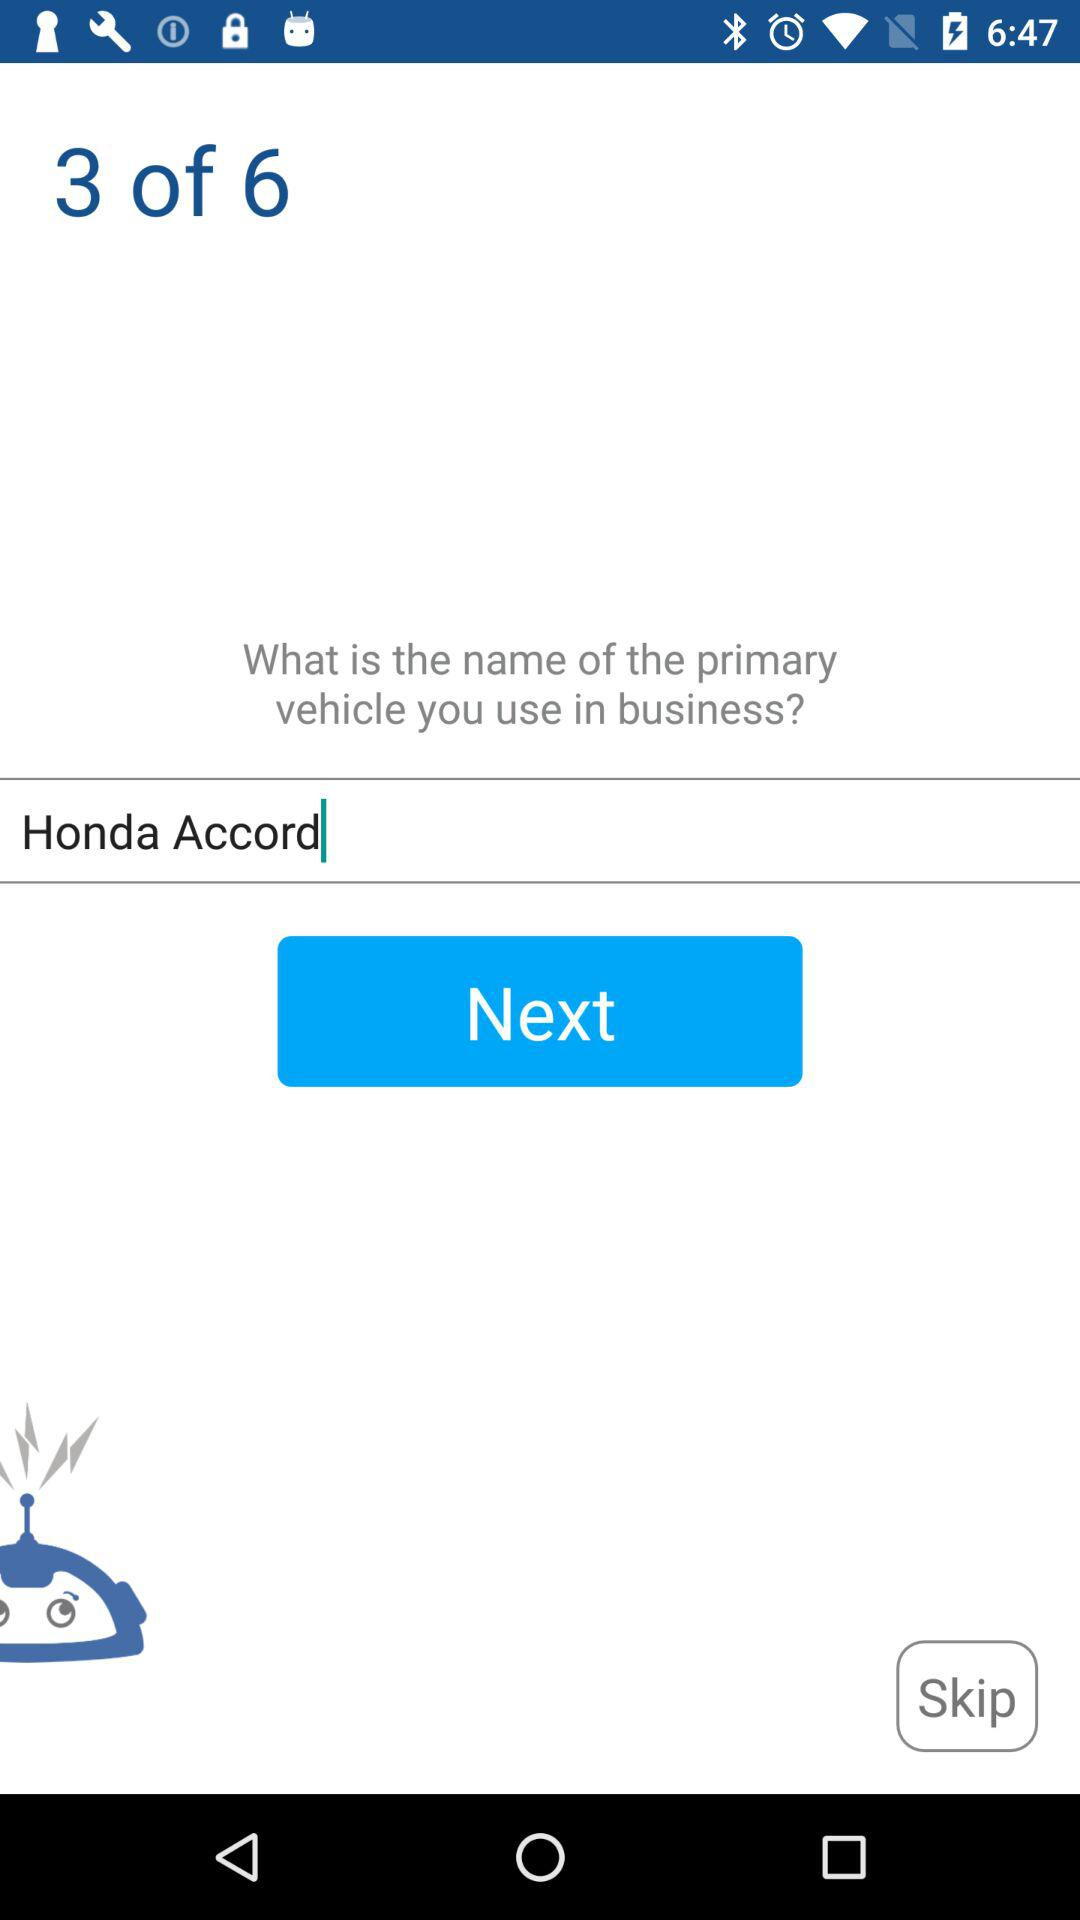Out of the 6 pages, what page are we currently on? You are currently on page 3. 